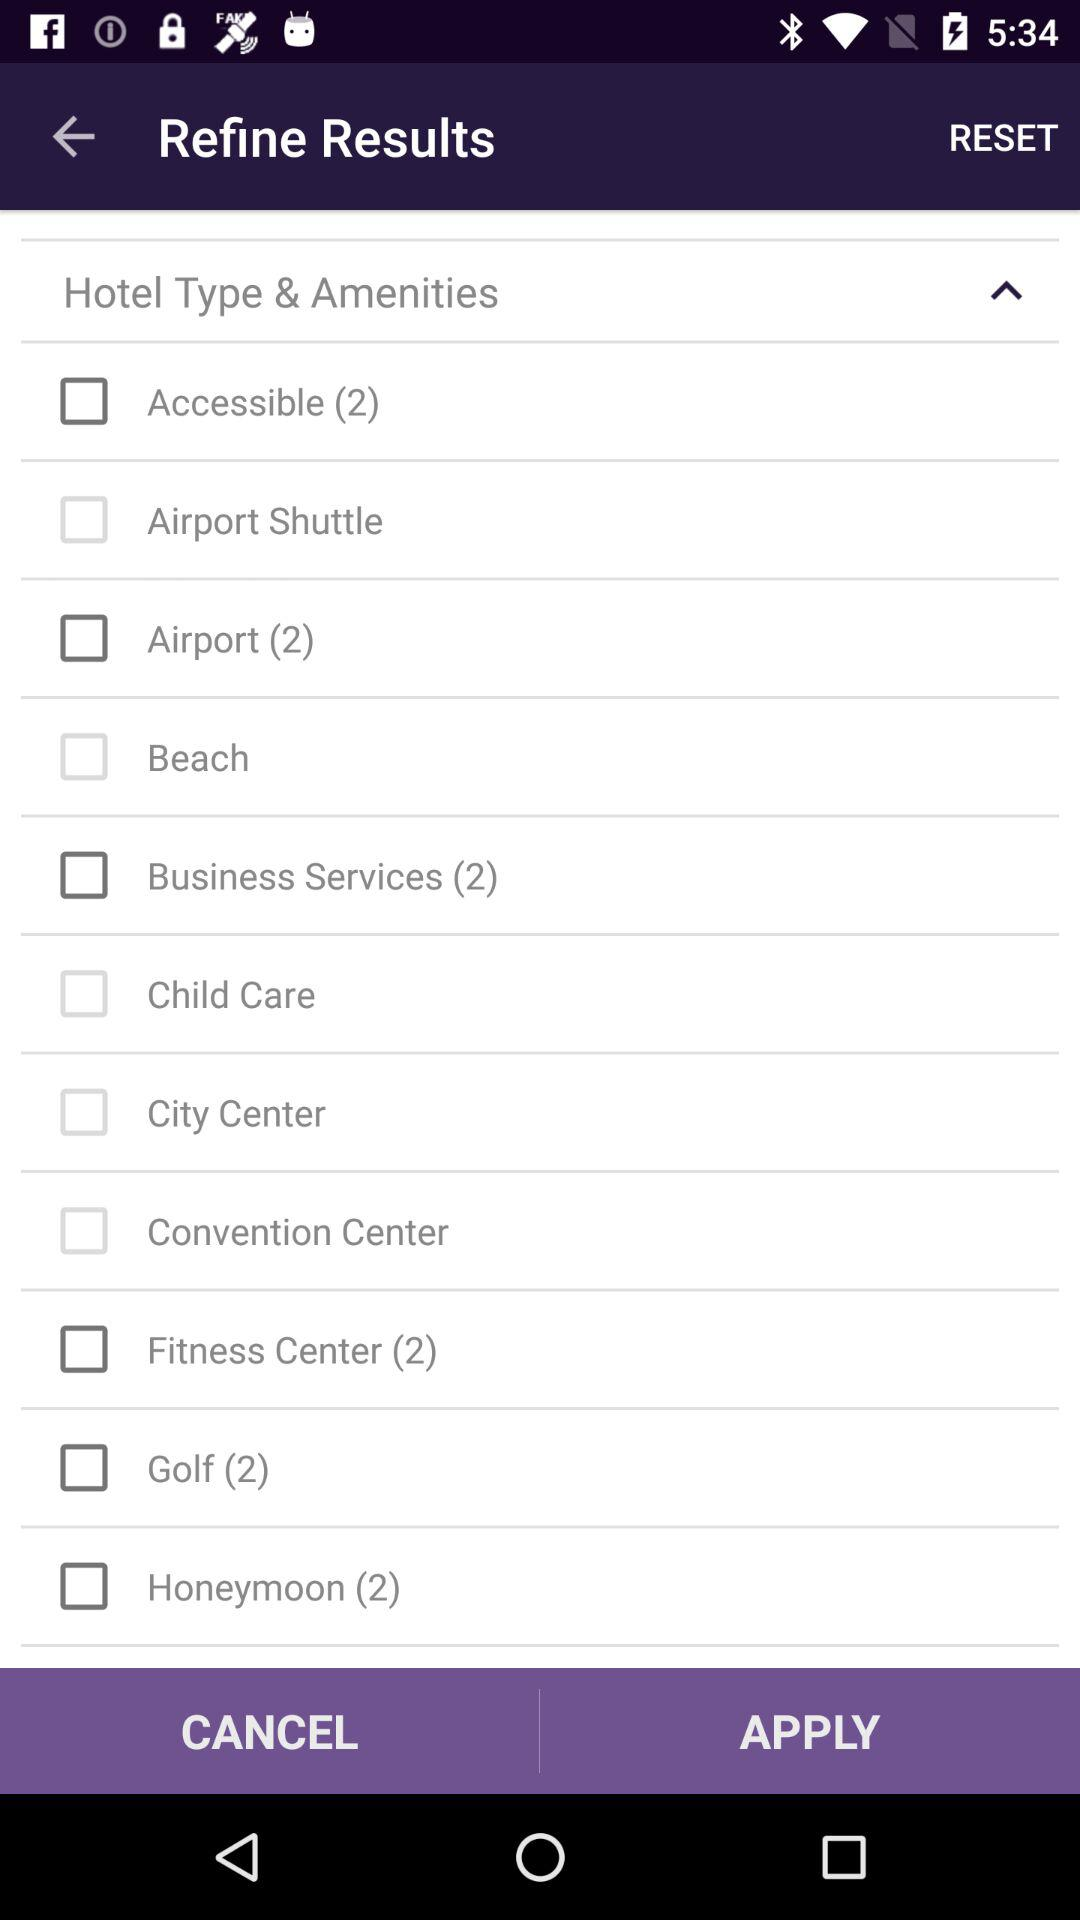What is the number of "Fitness Center" hotel types? The number is 2. 